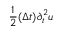Convert formula to latex. <formula><loc_0><loc_0><loc_500><loc_500>\frac { 1 } { 2 } ( \Delta t ) \partial _ { t } ^ { 2 } u</formula> 